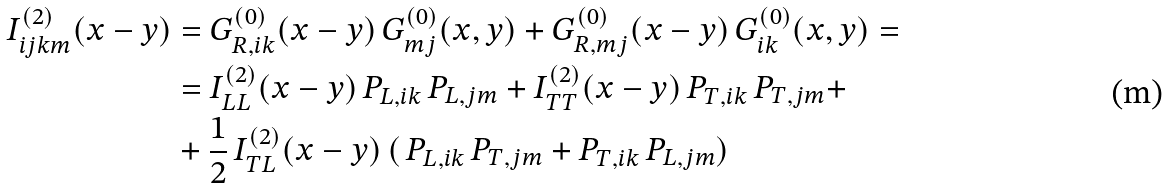Convert formula to latex. <formula><loc_0><loc_0><loc_500><loc_500>I _ { i j k m } ^ { ( 2 ) } ( x - y ) & = G ^ { ( 0 ) } _ { R , i k } ( x - y ) \, G ^ { ( 0 ) } _ { m j } ( x , y ) + G ^ { ( 0 ) } _ { R , m j } ( x - y ) \, G ^ { ( 0 ) } _ { i k } ( x , y ) = \\ & = I _ { L L } ^ { ( 2 ) } ( x - y ) \, P _ { L , i k } \, P _ { L , j m } + I _ { T T } ^ { ( 2 ) } ( x - y ) \, P _ { T , i k } \, P _ { T , j m } + \\ & + \frac { 1 } { 2 } \, I ^ { ( 2 ) } _ { T L } ( x - y ) \, ( \, P _ { L , i k } \, P _ { T , j m } + P _ { T , i k } \, P _ { L , j m } )</formula> 